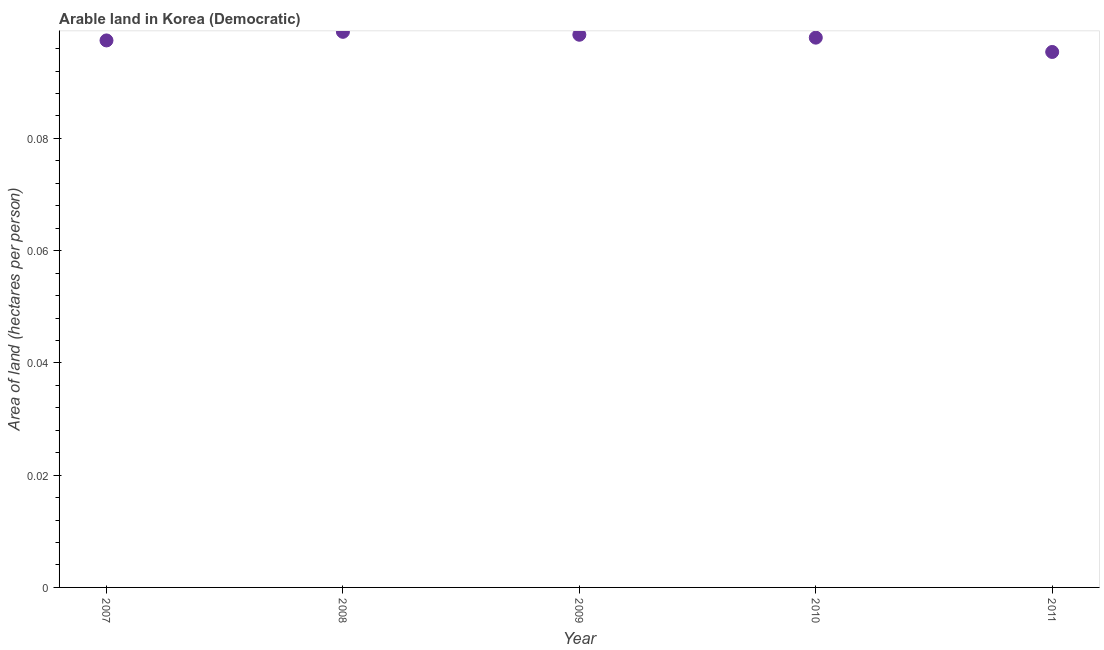What is the area of arable land in 2007?
Give a very brief answer. 0.1. Across all years, what is the maximum area of arable land?
Keep it short and to the point. 0.1. Across all years, what is the minimum area of arable land?
Ensure brevity in your answer.  0.1. In which year was the area of arable land minimum?
Keep it short and to the point. 2011. What is the sum of the area of arable land?
Provide a short and direct response. 0.49. What is the difference between the area of arable land in 2008 and 2010?
Make the answer very short. 0. What is the average area of arable land per year?
Ensure brevity in your answer.  0.1. What is the median area of arable land?
Make the answer very short. 0.1. What is the ratio of the area of arable land in 2008 to that in 2011?
Your answer should be compact. 1.04. What is the difference between the highest and the second highest area of arable land?
Offer a terse response. 0. Is the sum of the area of arable land in 2009 and 2010 greater than the maximum area of arable land across all years?
Give a very brief answer. Yes. What is the difference between the highest and the lowest area of arable land?
Your answer should be compact. 0. Does the area of arable land monotonically increase over the years?
Give a very brief answer. No. Are the values on the major ticks of Y-axis written in scientific E-notation?
Offer a terse response. No. Does the graph contain any zero values?
Offer a terse response. No. Does the graph contain grids?
Ensure brevity in your answer.  No. What is the title of the graph?
Offer a very short reply. Arable land in Korea (Democratic). What is the label or title of the X-axis?
Provide a short and direct response. Year. What is the label or title of the Y-axis?
Keep it short and to the point. Area of land (hectares per person). What is the Area of land (hectares per person) in 2007?
Provide a succinct answer. 0.1. What is the Area of land (hectares per person) in 2008?
Offer a terse response. 0.1. What is the Area of land (hectares per person) in 2009?
Give a very brief answer. 0.1. What is the Area of land (hectares per person) in 2010?
Your answer should be compact. 0.1. What is the Area of land (hectares per person) in 2011?
Give a very brief answer. 0.1. What is the difference between the Area of land (hectares per person) in 2007 and 2008?
Provide a short and direct response. -0. What is the difference between the Area of land (hectares per person) in 2007 and 2009?
Keep it short and to the point. -0. What is the difference between the Area of land (hectares per person) in 2007 and 2010?
Your answer should be compact. -0. What is the difference between the Area of land (hectares per person) in 2007 and 2011?
Ensure brevity in your answer.  0. What is the difference between the Area of land (hectares per person) in 2008 and 2009?
Your answer should be compact. 0. What is the difference between the Area of land (hectares per person) in 2008 and 2010?
Keep it short and to the point. 0. What is the difference between the Area of land (hectares per person) in 2008 and 2011?
Offer a terse response. 0. What is the difference between the Area of land (hectares per person) in 2009 and 2010?
Your response must be concise. 0. What is the difference between the Area of land (hectares per person) in 2009 and 2011?
Your answer should be compact. 0. What is the difference between the Area of land (hectares per person) in 2010 and 2011?
Offer a very short reply. 0. What is the ratio of the Area of land (hectares per person) in 2007 to that in 2008?
Your answer should be very brief. 0.98. What is the ratio of the Area of land (hectares per person) in 2007 to that in 2009?
Give a very brief answer. 0.99. What is the ratio of the Area of land (hectares per person) in 2007 to that in 2011?
Your answer should be compact. 1.02. What is the ratio of the Area of land (hectares per person) in 2008 to that in 2009?
Offer a very short reply. 1. What is the ratio of the Area of land (hectares per person) in 2008 to that in 2011?
Offer a very short reply. 1.04. What is the ratio of the Area of land (hectares per person) in 2009 to that in 2010?
Offer a very short reply. 1. What is the ratio of the Area of land (hectares per person) in 2009 to that in 2011?
Make the answer very short. 1.03. 